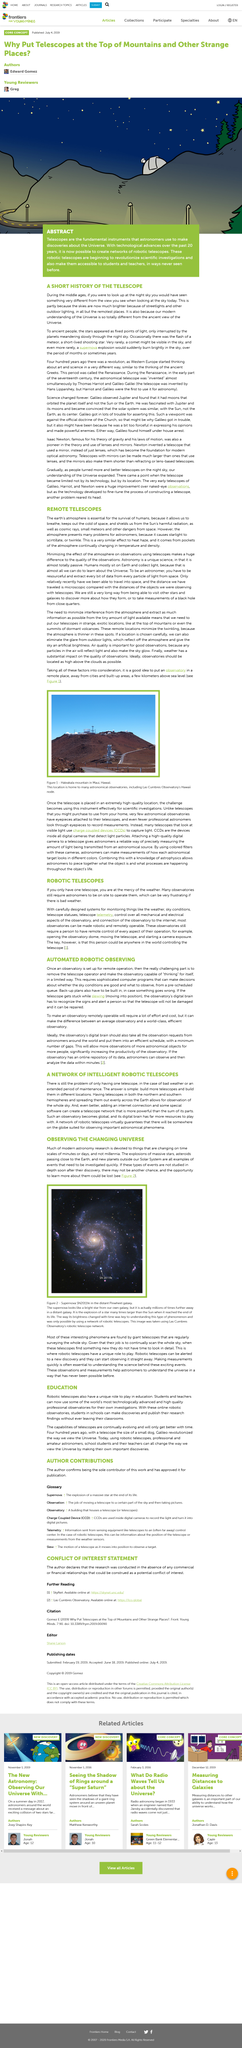Identify some key points in this picture. In ancient times, stars were perceived as fixed points of light in the sky. It is recommended that observatories be located at an altitude of a few kilometers above sea level, such as the Haleakala mountain in Maui, Hawaii, as shown in figure 1. Today's night sky is significantly brighter than it was during the Middle Ages due to the widespread use of streetlights and other outdoor lighting in both rural and urban areas. Most interesting phenomena are discovered through the use of a giant telescope. Telescopes are strategically positioned in remote and unique locations to minimize the negative impact of the Earth's atmosphere on their observations, thus maximizing their ability to gather valuable data from limited light sources. 